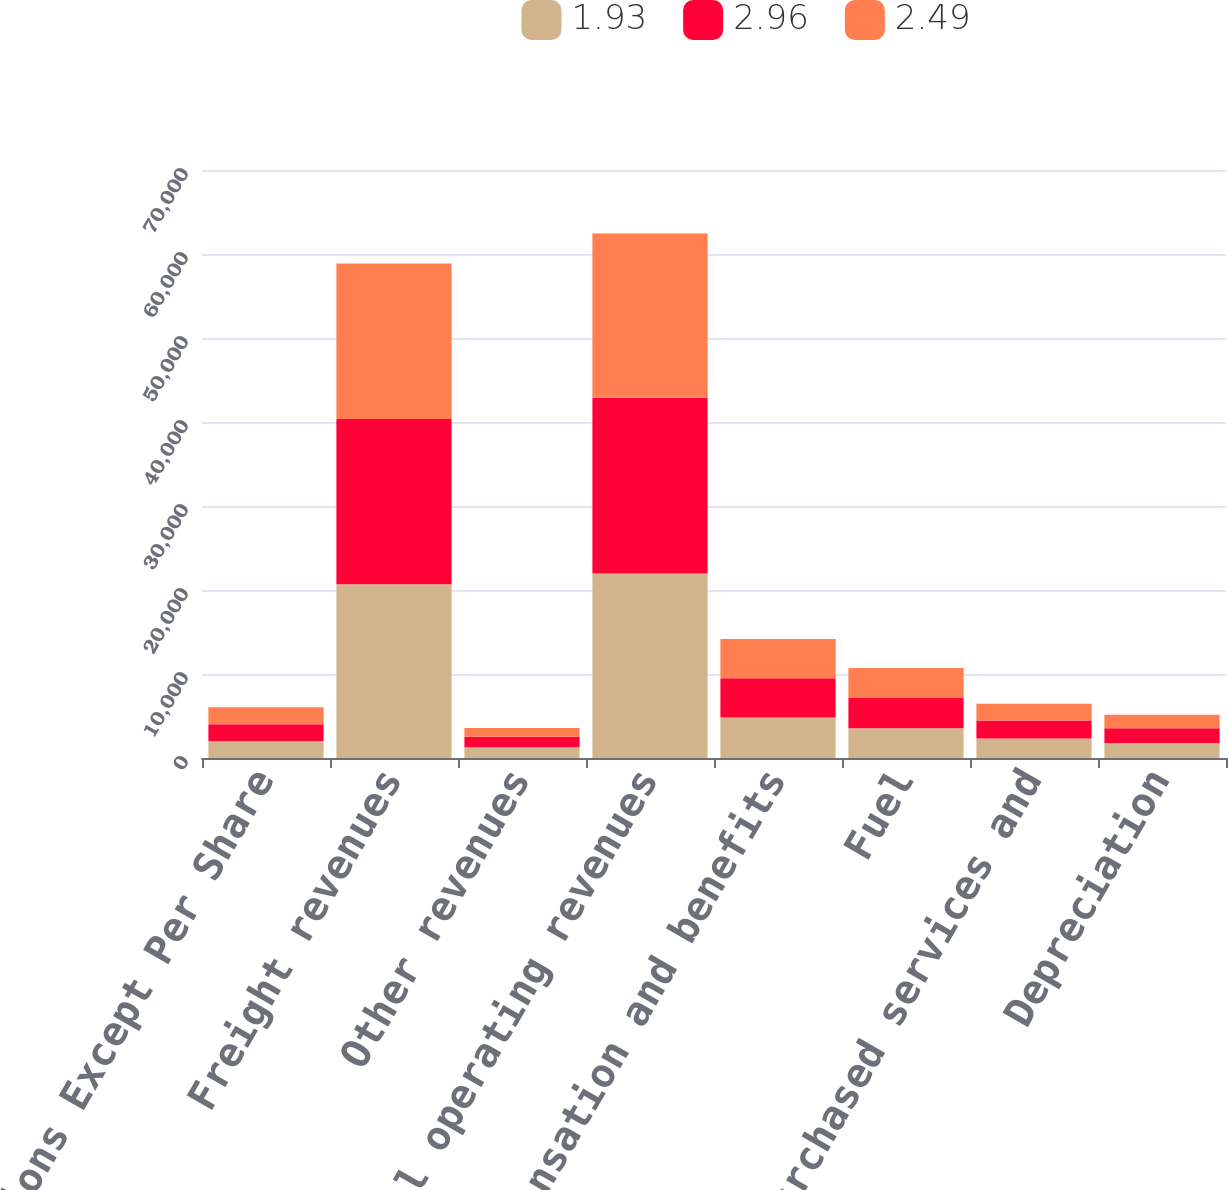Convert chart to OTSL. <chart><loc_0><loc_0><loc_500><loc_500><stacked_bar_chart><ecel><fcel>Millions Except Per Share<fcel>Freight revenues<fcel>Other revenues<fcel>Total operating revenues<fcel>Compensation and benefits<fcel>Fuel<fcel>Purchased services and<fcel>Depreciation<nl><fcel>1.93<fcel>2013<fcel>20684<fcel>1279<fcel>21963<fcel>4807<fcel>3534<fcel>2315<fcel>1777<nl><fcel>2.96<fcel>2012<fcel>19686<fcel>1240<fcel>20926<fcel>4685<fcel>3608<fcel>2143<fcel>1760<nl><fcel>2.49<fcel>2011<fcel>18508<fcel>1049<fcel>19557<fcel>4681<fcel>3581<fcel>2005<fcel>1617<nl></chart> 